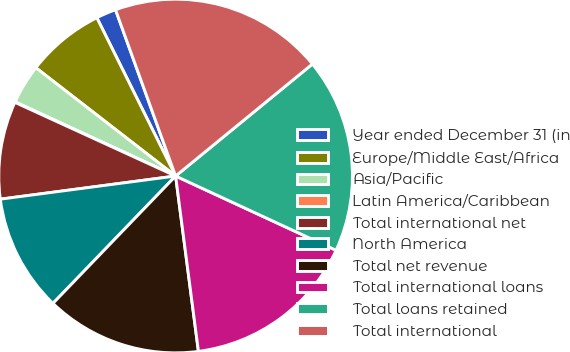Convert chart to OTSL. <chart><loc_0><loc_0><loc_500><loc_500><pie_chart><fcel>Year ended December 31 (in<fcel>Europe/Middle East/Africa<fcel>Asia/Pacific<fcel>Latin America/Caribbean<fcel>Total international net<fcel>North America<fcel>Total net revenue<fcel>Total international loans<fcel>Total loans retained<fcel>Total international<nl><fcel>1.83%<fcel>7.16%<fcel>3.6%<fcel>0.05%<fcel>8.93%<fcel>10.71%<fcel>14.26%<fcel>16.04%<fcel>17.82%<fcel>19.6%<nl></chart> 